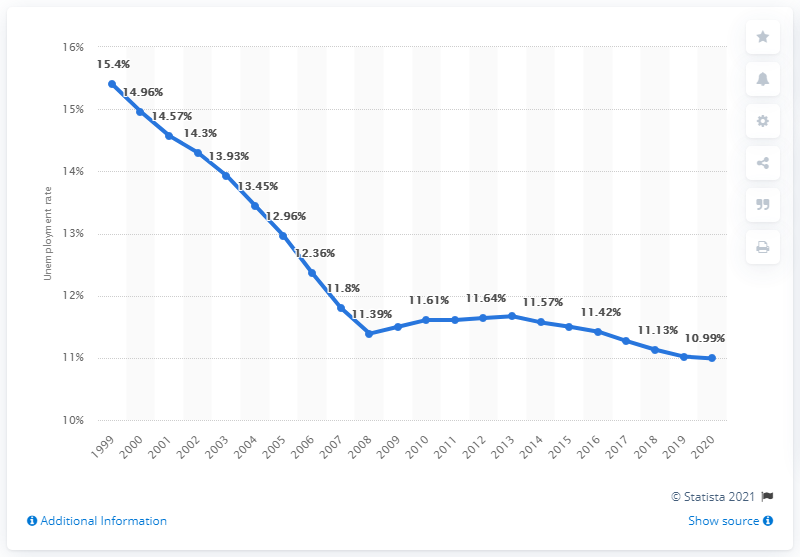Highlight a few significant elements in this photo. The unemployment rate in Tajikistan in 2020 was 10.99%. 